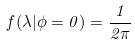Convert formula to latex. <formula><loc_0><loc_0><loc_500><loc_500>f ( \lambda | \phi = 0 ) = \frac { 1 } { 2 \pi }</formula> 